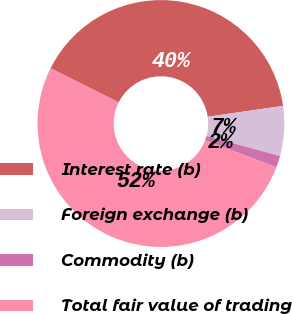Convert chart. <chart><loc_0><loc_0><loc_500><loc_500><pie_chart><fcel>Interest rate (b)<fcel>Foreign exchange (b)<fcel>Commodity (b)<fcel>Total fair value of trading<nl><fcel>40.33%<fcel>6.53%<fcel>1.52%<fcel>51.61%<nl></chart> 